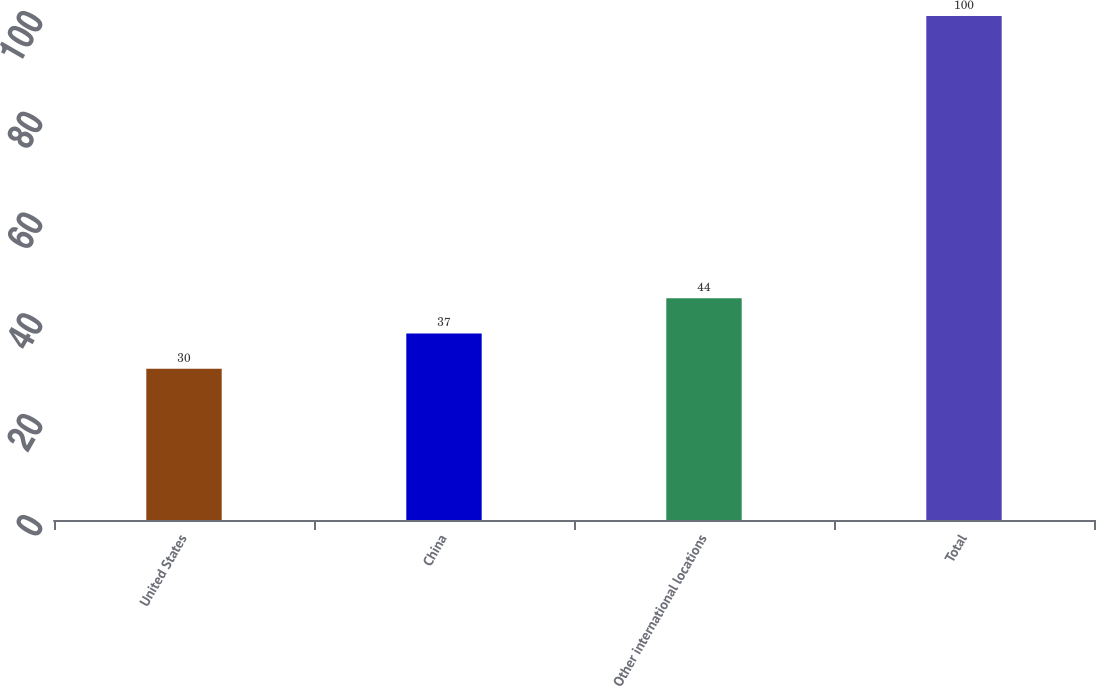Convert chart to OTSL. <chart><loc_0><loc_0><loc_500><loc_500><bar_chart><fcel>United States<fcel>China<fcel>Other international locations<fcel>Total<nl><fcel>30<fcel>37<fcel>44<fcel>100<nl></chart> 